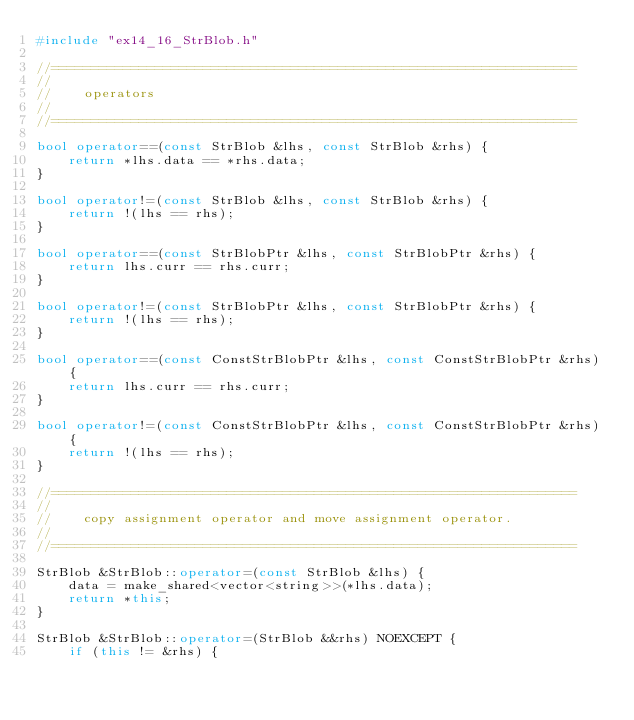Convert code to text. <code><loc_0><loc_0><loc_500><loc_500><_C++_>#include "ex14_16_StrBlob.h"

//==================================================================
//
//		operators
//
//==================================================================

bool operator==(const StrBlob &lhs, const StrBlob &rhs) {
    return *lhs.data == *rhs.data;
}

bool operator!=(const StrBlob &lhs, const StrBlob &rhs) {
    return !(lhs == rhs);
}

bool operator==(const StrBlobPtr &lhs, const StrBlobPtr &rhs) {
    return lhs.curr == rhs.curr;
}

bool operator!=(const StrBlobPtr &lhs, const StrBlobPtr &rhs) {
    return !(lhs == rhs);
}

bool operator==(const ConstStrBlobPtr &lhs, const ConstStrBlobPtr &rhs) {
    return lhs.curr == rhs.curr;
}

bool operator!=(const ConstStrBlobPtr &lhs, const ConstStrBlobPtr &rhs) {
    return !(lhs == rhs);
}

//==================================================================
//
//		copy assignment operator and move assignment operator.
//
//==================================================================

StrBlob &StrBlob::operator=(const StrBlob &lhs) {
    data = make_shared<vector<string>>(*lhs.data);
    return *this;
}

StrBlob &StrBlob::operator=(StrBlob &&rhs) NOEXCEPT {
    if (this != &rhs) {</code> 